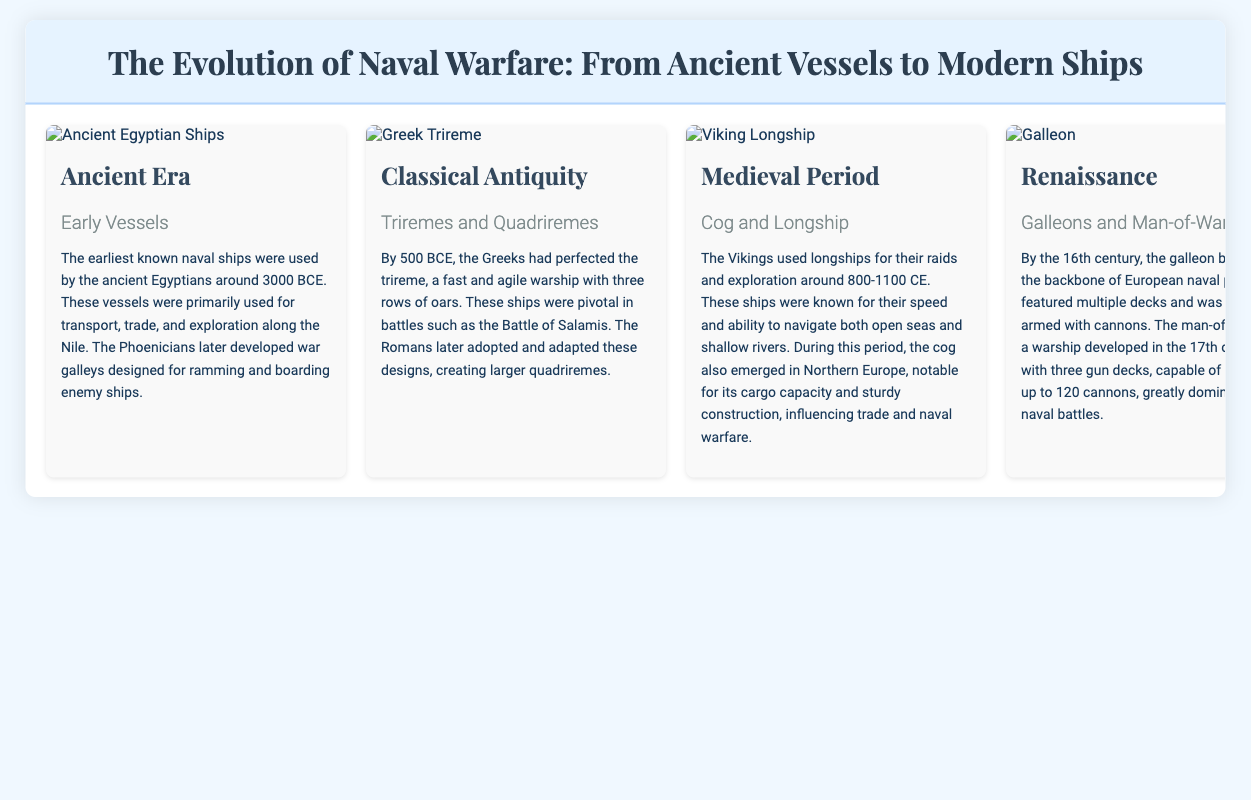What year were the earliest known naval ships used? The document states that the earliest known naval ships were used by the ancient Egyptians around 3000 BCE.
Answer: 3000 BCE Which ship design was perfected by the Greeks by 500 BCE? The document mentions that the Greeks perfected the trireme by 500 BCE, a fast and agile warship.
Answer: Trireme What type of ship did the Vikings predominantly use for their raids? According to the document, the Vikings used longships for their raids and exploration.
Answer: Longship What innovation marked a significant advancement in naval warfare in the 18th-19th century? The document indicates that steam-powered ships and ironclad warships represented significant advancements in naval warfare during this time.
Answer: Ironclads How many cannons could the man-of-war typically carry? The document states that the man-of-war was capable of carrying up to 120 cannons.
Answer: 120 cannons What major naval vehicle became essential for projecting air power during World War I and II? The document notes that aircraft carriers became essential for projecting air power during the world wars.
Answer: Aircraft carriers Which era saw the development of galleons as the backbone of European naval power? The document indicates that during the Renaissance or by the 16th century, galleons became the backbone of European naval power.
Answer: Renaissance What role did submarines play in naval strategy during the 20th century? The document explains that submarines became a crucial part of naval strategy due to their stealth capabilities and ability to launch torpedoes and missiles.
Answer: Stealth capabilities What type of document is this presentation classified as? The document is a presentation slide that visually details the evolution of naval warfare.
Answer: Presentation slide 